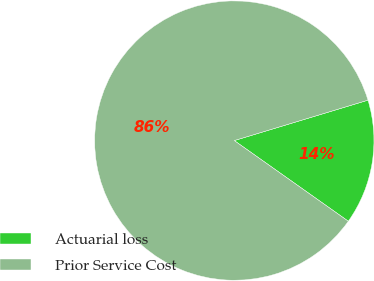Convert chart to OTSL. <chart><loc_0><loc_0><loc_500><loc_500><pie_chart><fcel>Actuarial loss<fcel>Prior Service Cost<nl><fcel>14.47%<fcel>85.53%<nl></chart> 